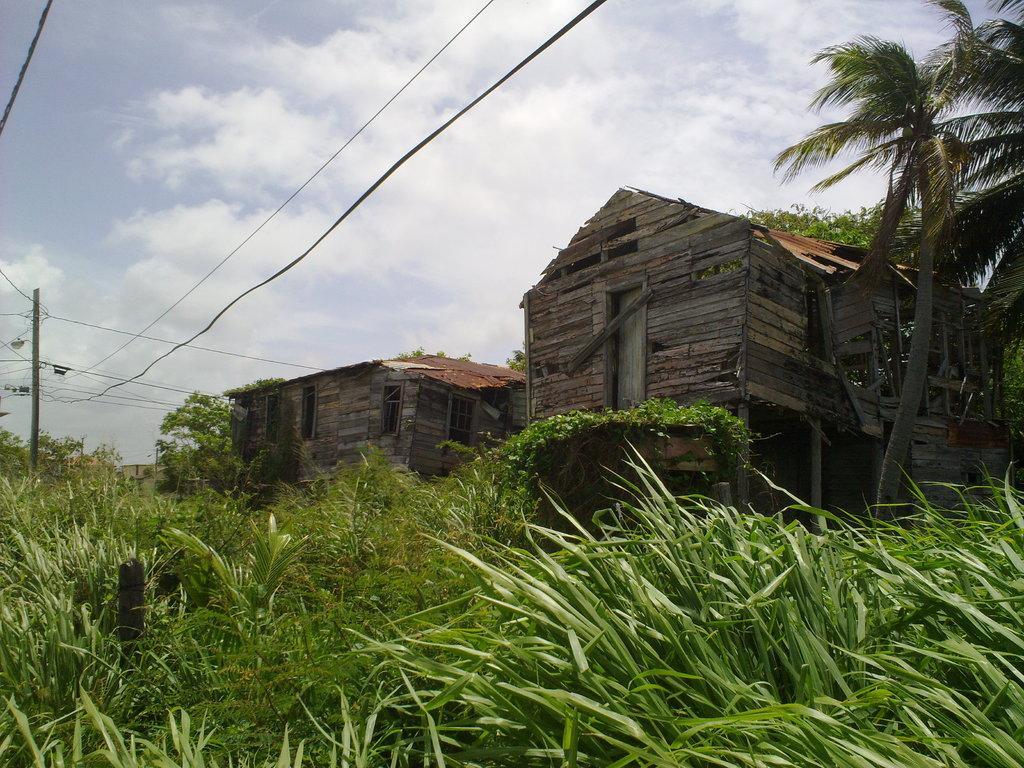Can you describe this image briefly? This image is taken outdoors. At the bottom of the image there is a ground with grass and many plants on it. At the top of the image there is a sky with clouds. In the middle of the image there are a few trees and there are two houses. On the left side of the image there is a pole with a few wires. 